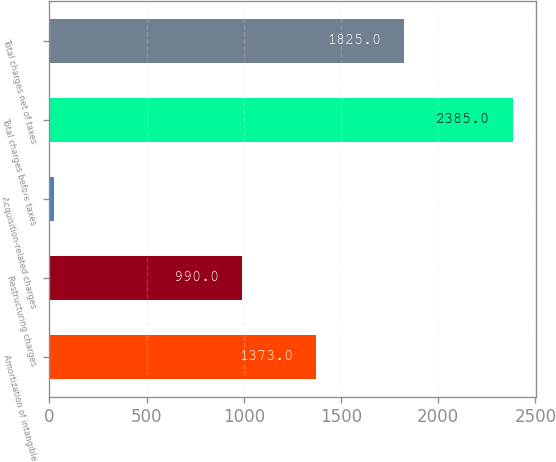<chart> <loc_0><loc_0><loc_500><loc_500><bar_chart><fcel>Amortization of intangible<fcel>Restructuring charges<fcel>Acquisition-related charges<fcel>Total charges before taxes<fcel>Total charges net of taxes<nl><fcel>1373<fcel>990<fcel>22<fcel>2385<fcel>1825<nl></chart> 